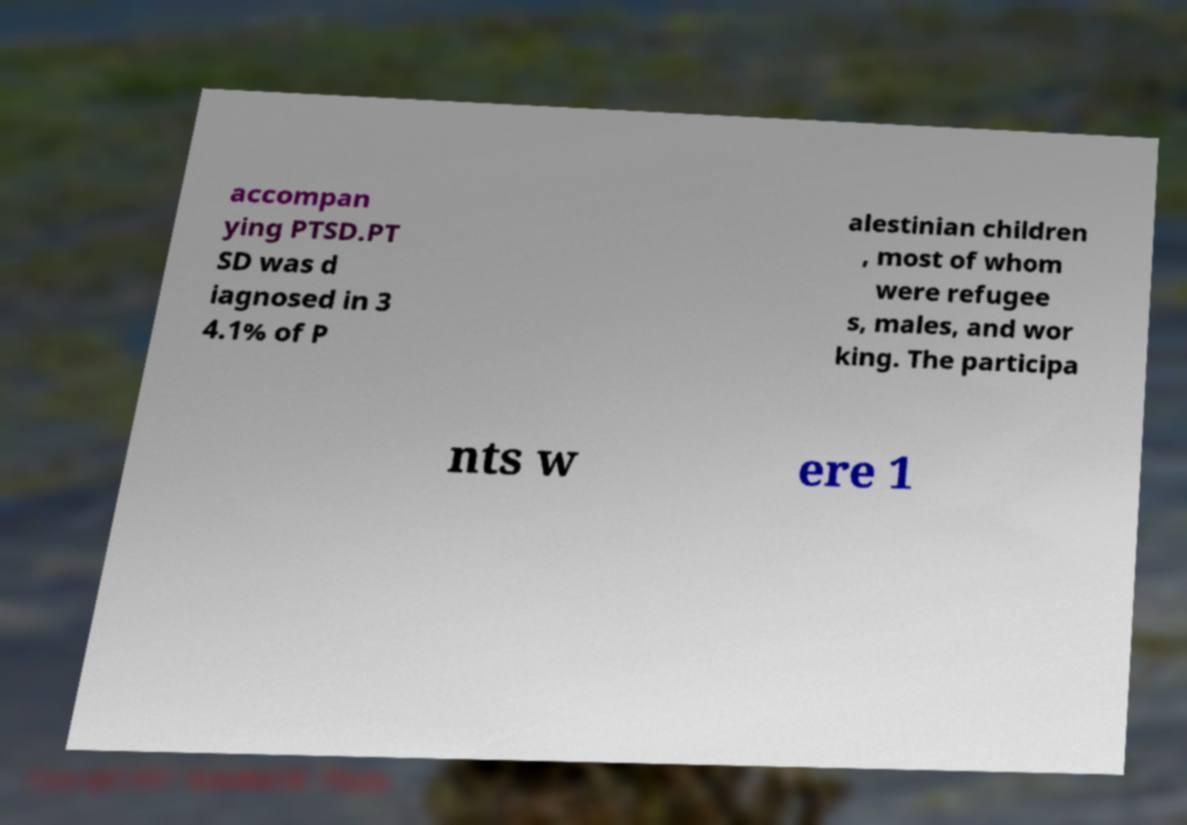Can you read and provide the text displayed in the image?This photo seems to have some interesting text. Can you extract and type it out for me? accompan ying PTSD.PT SD was d iagnosed in 3 4.1% of P alestinian children , most of whom were refugee s, males, and wor king. The participa nts w ere 1 